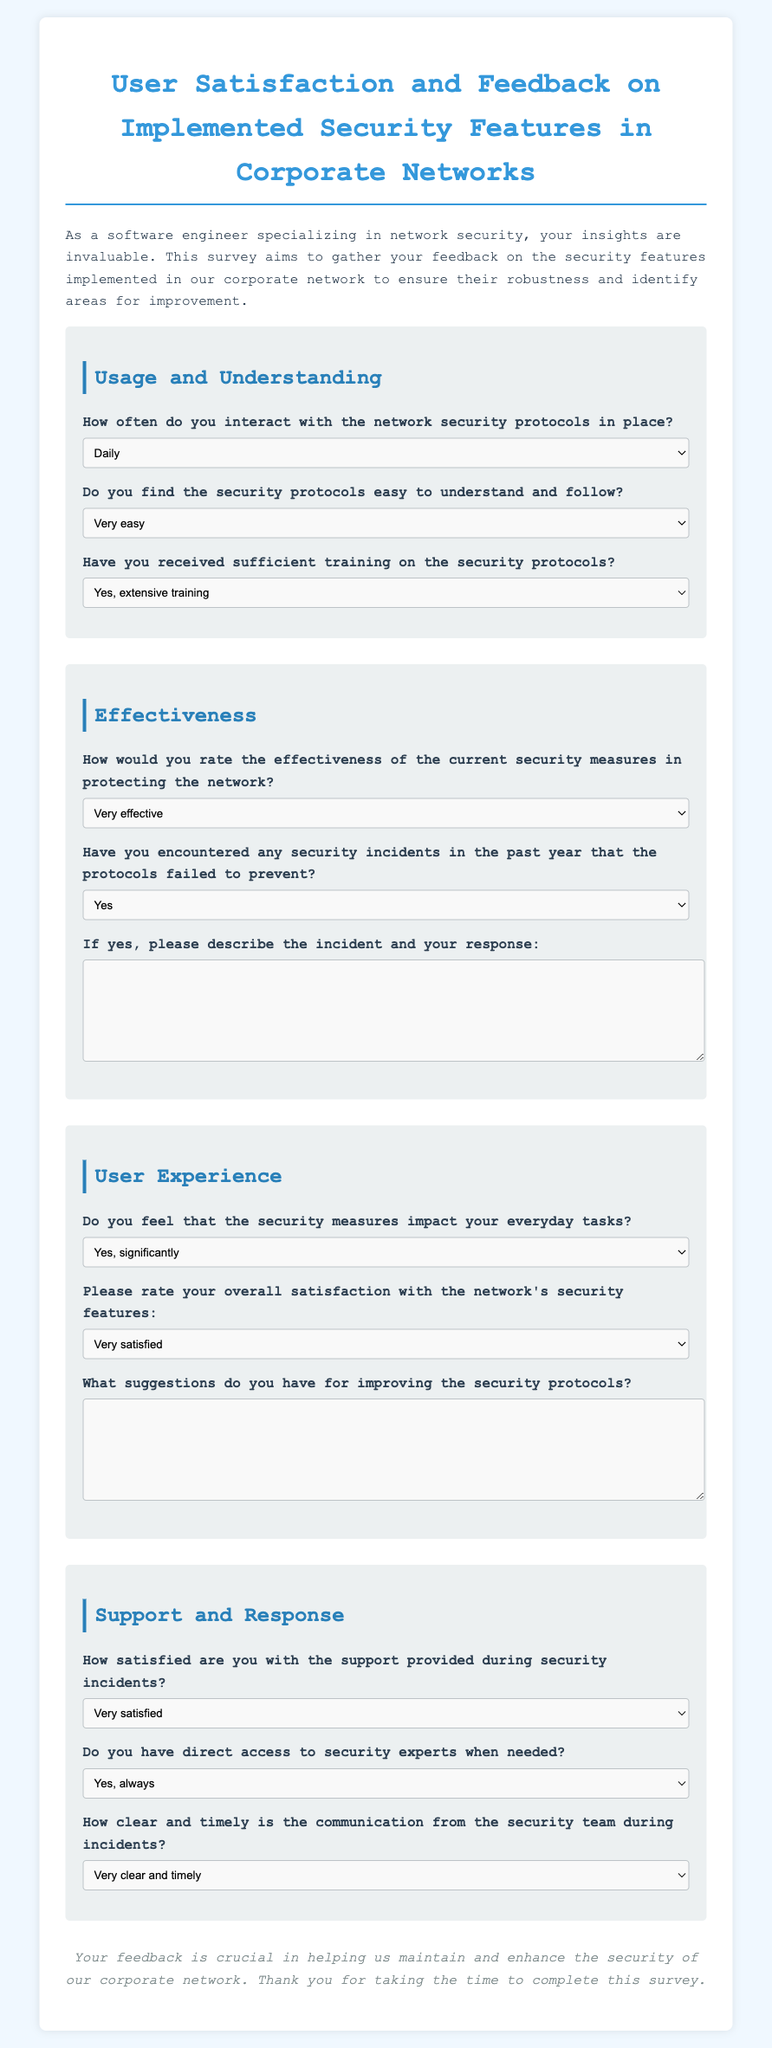How often do you interact with the network security protocols in place? This question asks about the frequency of interaction with security protocols and has options like Daily, Weekly, Monthly, and Rarely.
Answer: Daily Do you find the security protocols easy to understand and follow? This question provides options rating the ease of understanding the protocols, ranging from Very easy to Very difficult.
Answer: Very easy How effective are the current security measures in protecting the network? This question seeks a rating on the effectiveness of security measures, with options from Very effective to Very ineffective.
Answer: Very effective Have you encountered any security incidents in the past year that the protocols failed to prevent? This question is a yes/no question regarding experiencing incidents that the protocols did not mitigate.
Answer: Yes How satisfied are you with the support provided during security incidents? This question assesses the satisfaction level with support during incidents, ranging from Very satisfied to Very dissatisfied.
Answer: Satisfied What suggestions do you have for improving the security protocols? This is an open-ended question inviting opinions on enhancing security measures, allowing for a variety of responses.
Answer: Improved training Do you have direct access to security experts when needed? This asks about the availability of security experts for consultation, with responses from Yes, always to Never.
Answer: Yes, always How clear and timely is the communication from the security team during incidents? This question assesses the quality of communication during incidents, with ratings from Very clear and timely to Very unclear and untimely.
Answer: Clear and timely What is the overall satisfaction rating of the network's security features? This asks for a general satisfaction rating from Very satisfied to Very dissatisfied regarding security functionalities.
Answer: Satisfied 